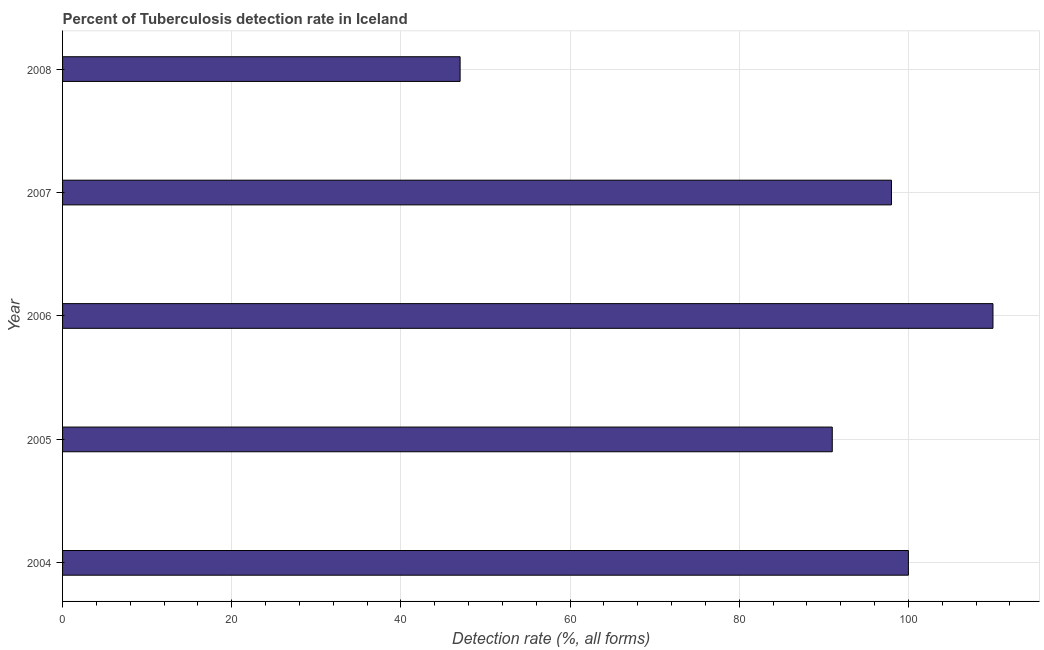What is the title of the graph?
Provide a succinct answer. Percent of Tuberculosis detection rate in Iceland. What is the label or title of the X-axis?
Offer a terse response. Detection rate (%, all forms). What is the detection rate of tuberculosis in 2004?
Provide a succinct answer. 100. Across all years, what is the maximum detection rate of tuberculosis?
Make the answer very short. 110. What is the sum of the detection rate of tuberculosis?
Your answer should be compact. 446. What is the difference between the detection rate of tuberculosis in 2007 and 2008?
Your answer should be compact. 51. What is the average detection rate of tuberculosis per year?
Offer a terse response. 89. Do a majority of the years between 2006 and 2005 (inclusive) have detection rate of tuberculosis greater than 44 %?
Ensure brevity in your answer.  No. What is the ratio of the detection rate of tuberculosis in 2004 to that in 2006?
Make the answer very short. 0.91. Is the detection rate of tuberculosis in 2006 less than that in 2008?
Make the answer very short. No. In how many years, is the detection rate of tuberculosis greater than the average detection rate of tuberculosis taken over all years?
Keep it short and to the point. 4. How many bars are there?
Offer a terse response. 5. Are all the bars in the graph horizontal?
Ensure brevity in your answer.  Yes. How many years are there in the graph?
Keep it short and to the point. 5. What is the Detection rate (%, all forms) in 2005?
Give a very brief answer. 91. What is the Detection rate (%, all forms) in 2006?
Offer a terse response. 110. What is the Detection rate (%, all forms) of 2008?
Your answer should be compact. 47. What is the difference between the Detection rate (%, all forms) in 2004 and 2005?
Offer a terse response. 9. What is the difference between the Detection rate (%, all forms) in 2004 and 2007?
Your response must be concise. 2. What is the difference between the Detection rate (%, all forms) in 2005 and 2008?
Make the answer very short. 44. What is the difference between the Detection rate (%, all forms) in 2007 and 2008?
Offer a terse response. 51. What is the ratio of the Detection rate (%, all forms) in 2004 to that in 2005?
Provide a short and direct response. 1.1. What is the ratio of the Detection rate (%, all forms) in 2004 to that in 2006?
Give a very brief answer. 0.91. What is the ratio of the Detection rate (%, all forms) in 2004 to that in 2008?
Make the answer very short. 2.13. What is the ratio of the Detection rate (%, all forms) in 2005 to that in 2006?
Offer a very short reply. 0.83. What is the ratio of the Detection rate (%, all forms) in 2005 to that in 2007?
Give a very brief answer. 0.93. What is the ratio of the Detection rate (%, all forms) in 2005 to that in 2008?
Provide a succinct answer. 1.94. What is the ratio of the Detection rate (%, all forms) in 2006 to that in 2007?
Give a very brief answer. 1.12. What is the ratio of the Detection rate (%, all forms) in 2006 to that in 2008?
Ensure brevity in your answer.  2.34. What is the ratio of the Detection rate (%, all forms) in 2007 to that in 2008?
Your answer should be compact. 2.08. 